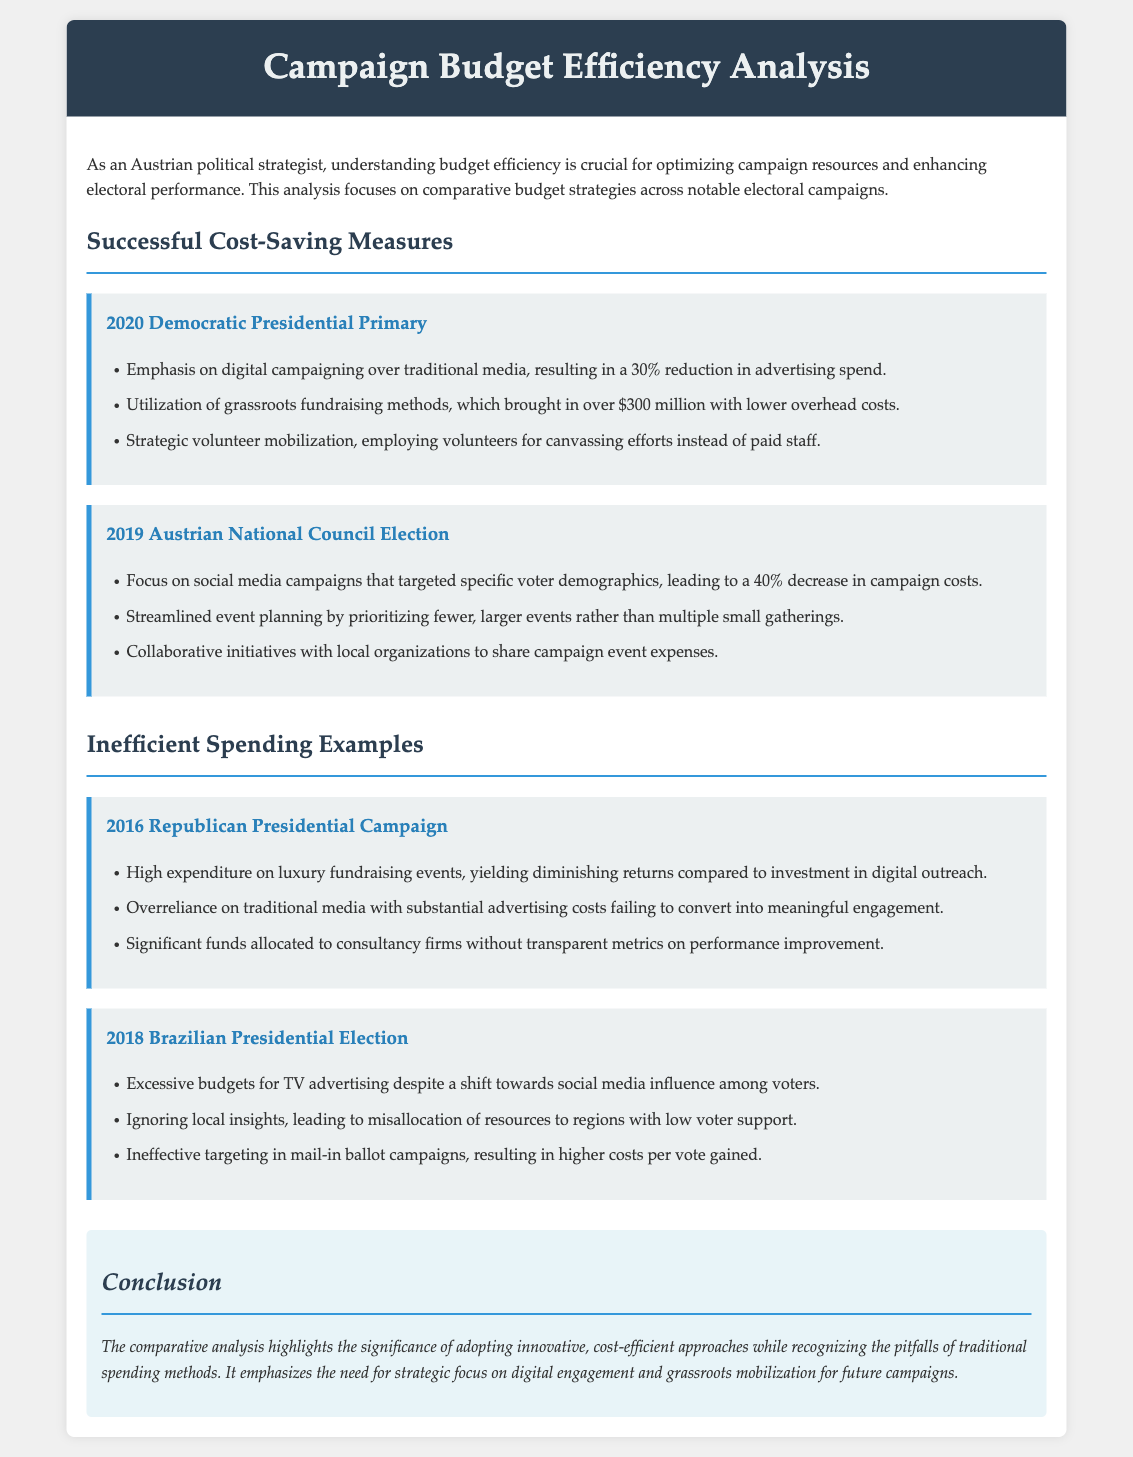What was the percentage reduction in advertising spend for the 2020 Democratic Presidential Primary? The document states there was a 30% reduction in advertising spend due to digital campaigning.
Answer: 30% What was the total amount raised through grassroots fundraising for the 2020 Democratic Presidential Primary? The document mentions that over $300 million was raised through grassroots fundraising methods.
Answer: $300 million Which electoral campaign focused on social media to achieve a 40% decrease in campaign costs? The analysis highlights the 2019 Austrian National Council Election as having a focus on social media campaigns.
Answer: 2019 Austrian National Council Election What type of events did the 2016 Republican Presidential Campaign spend heavily on? The document indicates that the campaign had high expenditure on luxury fundraising events.
Answer: Luxury fundraising events What was one significant spending mistake made during the 2018 Brazilian Presidential Election? The document mentions excessive budgets for TV advertising despite a shift toward social media influence as a mistake.
Answer: Excessive budgets for TV advertising Which campaign employed strategic volunteer mobilization instead of paid staff? The document states that the 2020 Democratic Presidential Primary used strategic volunteer mobilization for canvassing.
Answer: 2020 Democratic Presidential Primary What approach led to the misallocation of resources in the 2018 Brazilian Presidential Election? The document describes ignoring local insights as leading to misallocation of resources in that election.
Answer: Ignoring local insights What does the conclusion emphasize as a need for future campaigns? The conclusion emphasizes the need for strategic focus on digital engagement and grassroots mobilization for future campaigns.
Answer: Digital engagement and grassroots mobilization 